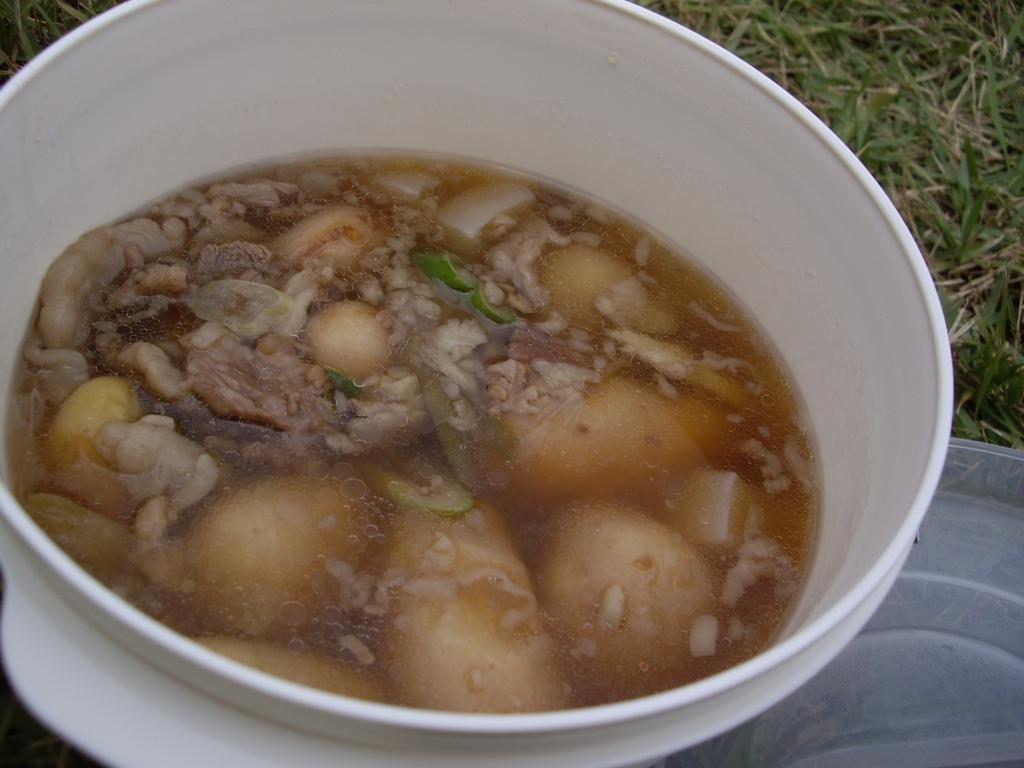What color is the bowl in the image? The bowl in the image is white. What is inside the bowl? The bowl contains a food item that is brown and green in color. What can be seen on the ground in the image? There is grass visible on the ground in the image. What type of neck accessory is visible on the grass in the image? There is no neck accessory visible on the grass in the image. What material is the steel object made of in the image? There is no steel object present in the image. 